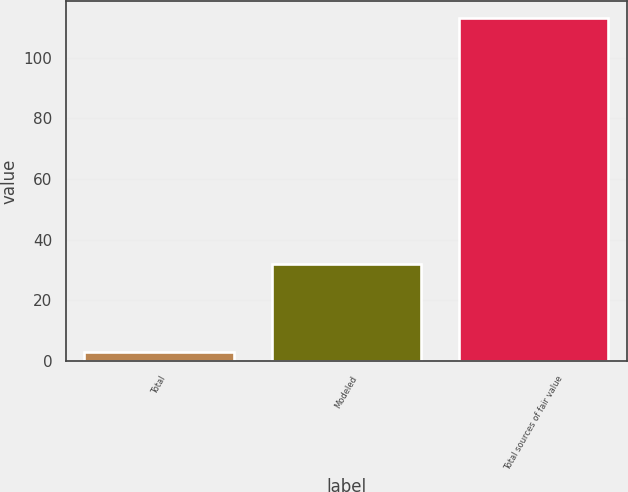Convert chart to OTSL. <chart><loc_0><loc_0><loc_500><loc_500><bar_chart><fcel>Total<fcel>Modeled<fcel>Total sources of fair value<nl><fcel>3<fcel>32<fcel>113<nl></chart> 